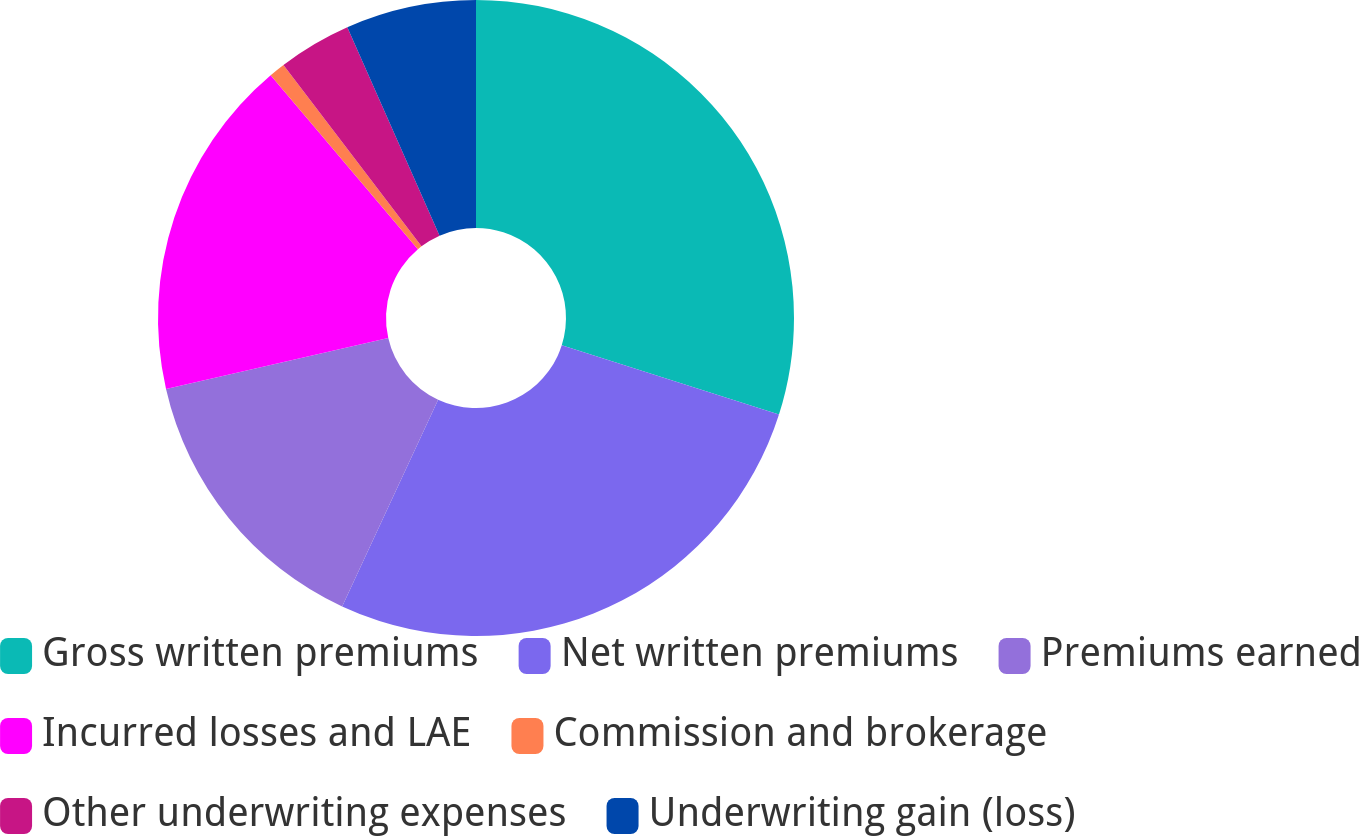Convert chart. <chart><loc_0><loc_0><loc_500><loc_500><pie_chart><fcel>Gross written premiums<fcel>Net written premiums<fcel>Premiums earned<fcel>Incurred losses and LAE<fcel>Commission and brokerage<fcel>Other underwriting expenses<fcel>Underwriting gain (loss)<nl><fcel>29.91%<fcel>27.0%<fcel>14.5%<fcel>17.41%<fcel>0.82%<fcel>3.72%<fcel>6.63%<nl></chart> 